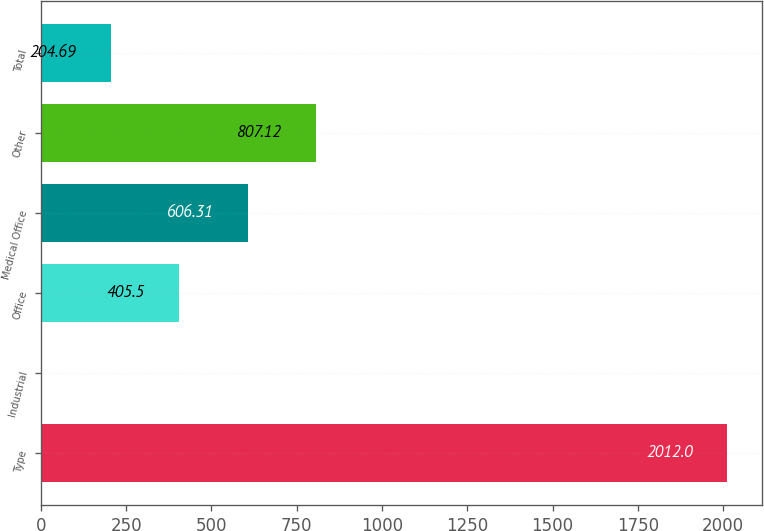Convert chart to OTSL. <chart><loc_0><loc_0><loc_500><loc_500><bar_chart><fcel>Type<fcel>Industrial<fcel>Office<fcel>Medical Office<fcel>Other<fcel>Total<nl><fcel>2012<fcel>3.88<fcel>405.5<fcel>606.31<fcel>807.12<fcel>204.69<nl></chart> 